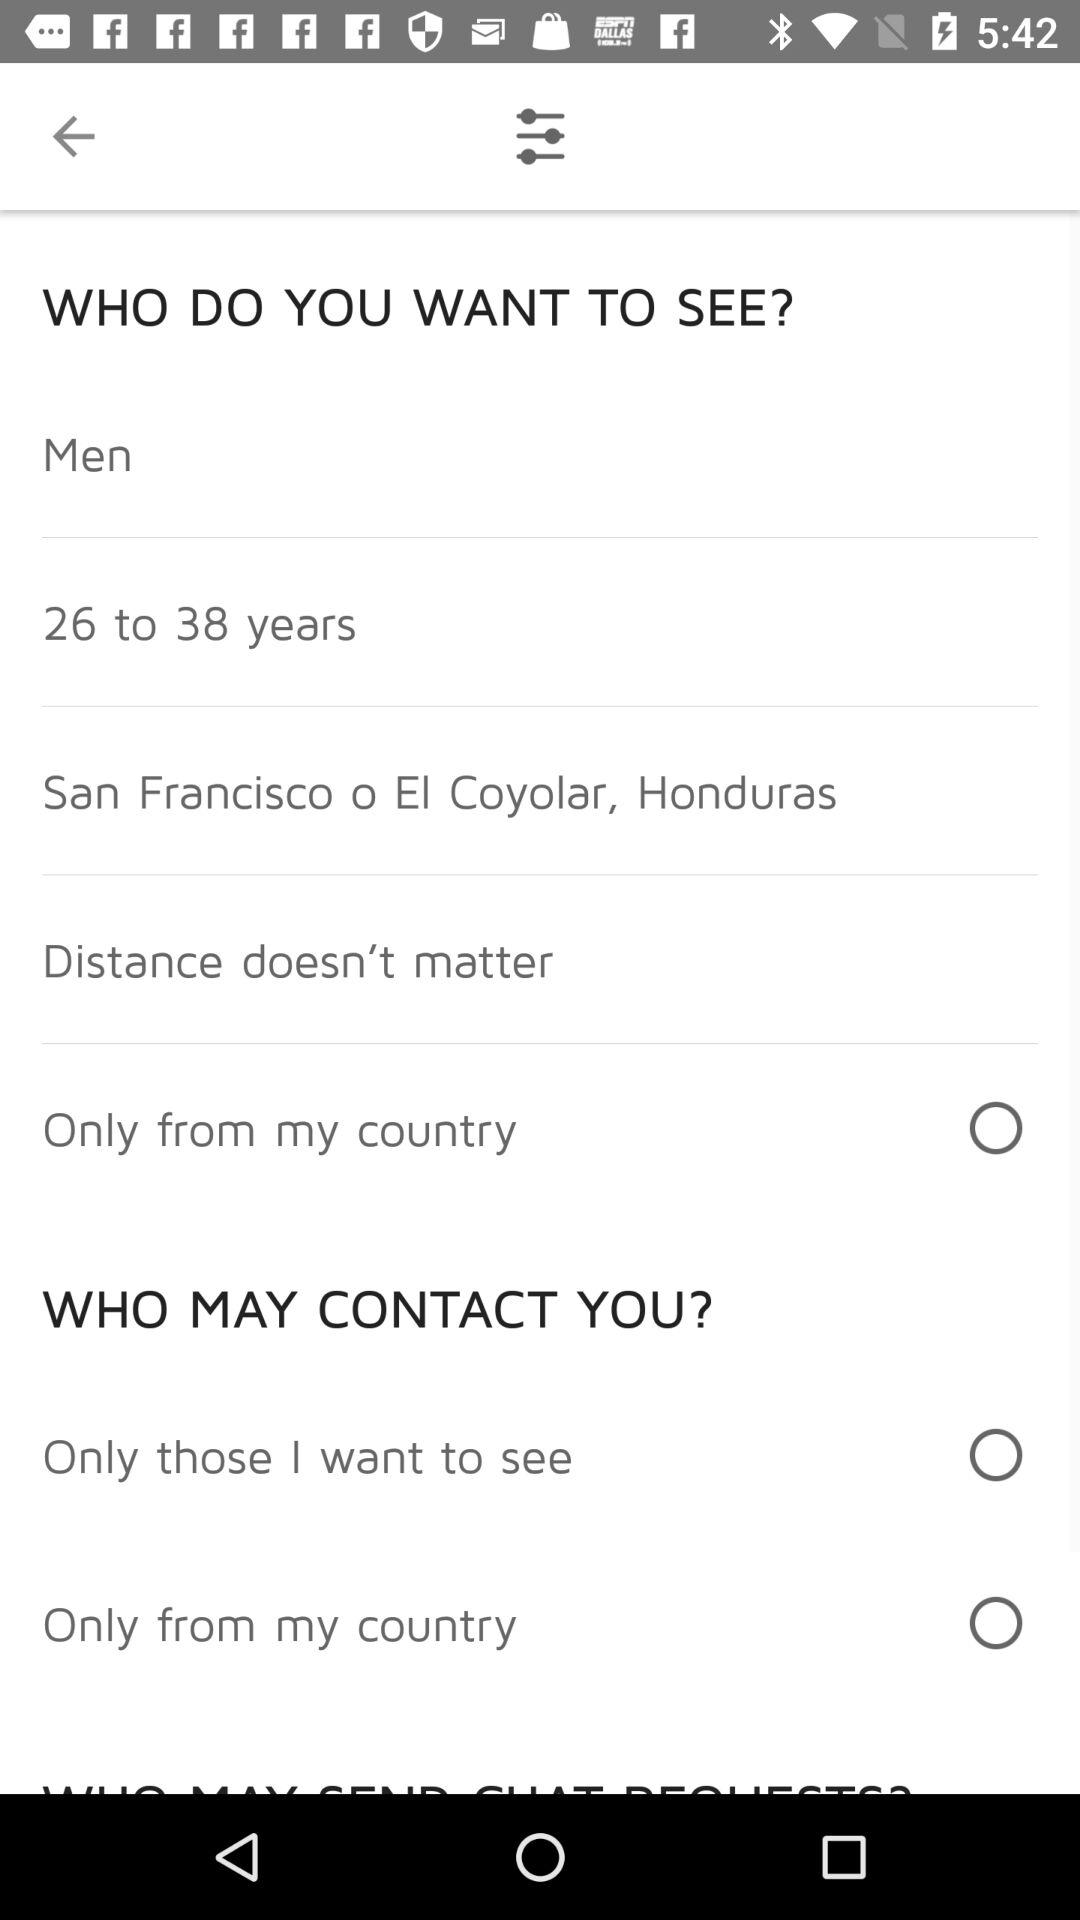What is the status of the "Only from my country"? The status is "off". 